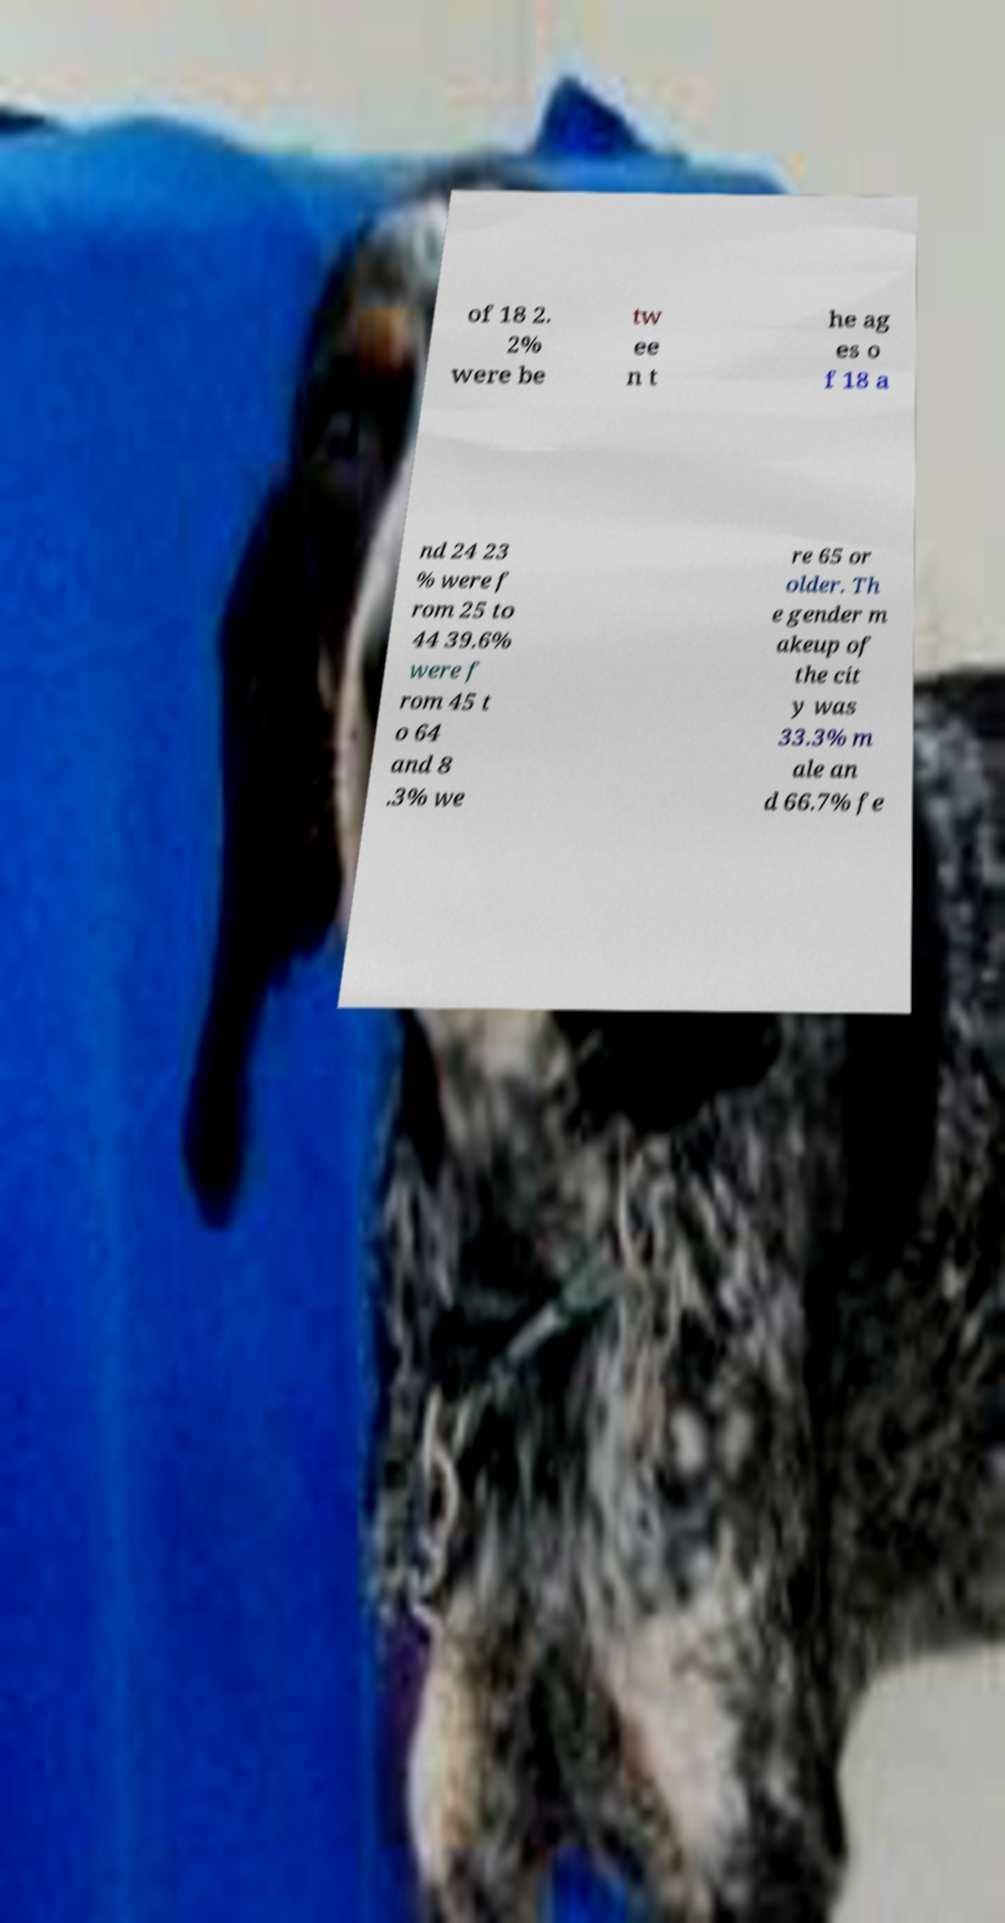I need the written content from this picture converted into text. Can you do that? of 18 2. 2% were be tw ee n t he ag es o f 18 a nd 24 23 % were f rom 25 to 44 39.6% were f rom 45 t o 64 and 8 .3% we re 65 or older. Th e gender m akeup of the cit y was 33.3% m ale an d 66.7% fe 